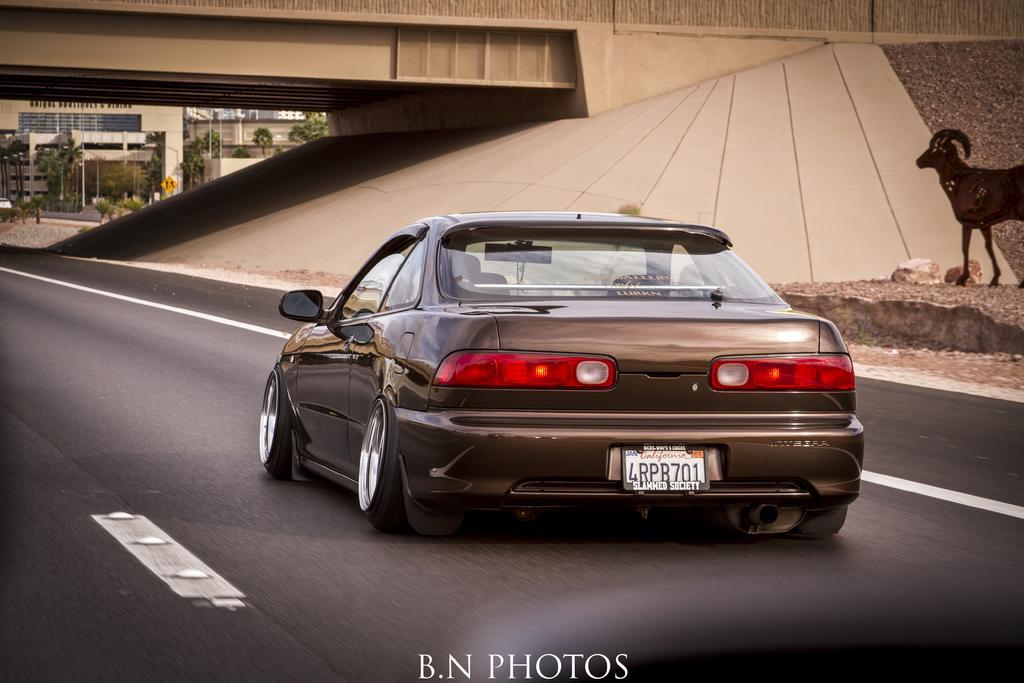In one or two sentences, can you explain what this image depicts? There is a road. On the road there is a car. On the right side we can see a painting of the goat on the wall. Also there are stone. There is a bridge. In the back there are trees and buildings. At the bottom there is a watermark on the image. 